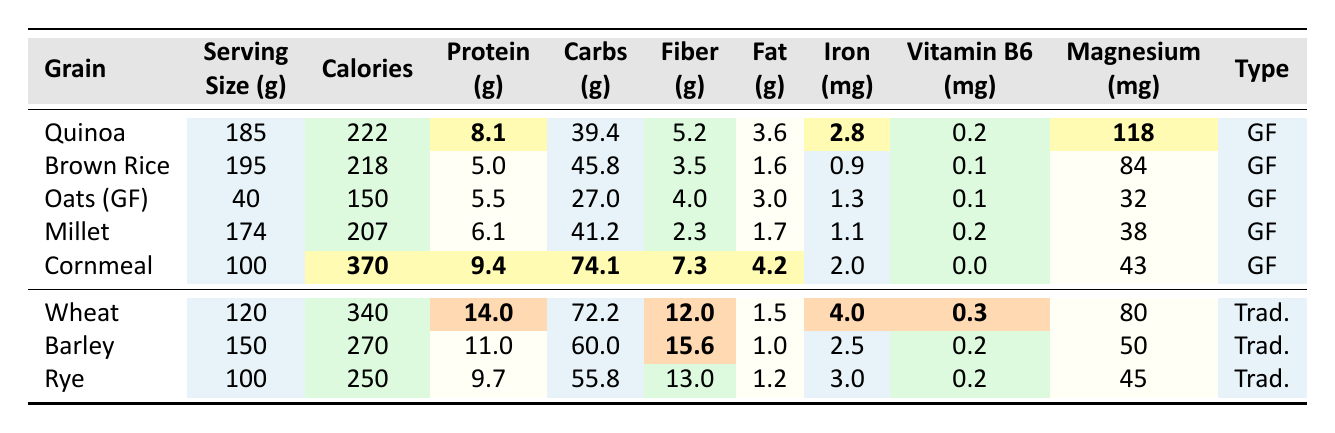What is the calorie content of Cornmeal? The table shows that Cornmeal has a calorie content of 370.
Answer: 370 Which grain has the highest protein content? By comparing the protein content of each grain, Wheat (Whole Grain) has the highest at 14.0 grams.
Answer: Wheat (Whole Grain) How much fiber is in Brown Rice? The table states that Brown Rice contains 3.5 grams of fiber.
Answer: 3.5 What is the total carbohydrate content of Quinoa and Millet? Quinoa has 39.4 grams and Millet has 41.2 grams. The total is 39.4 + 41.2 = 80.6 grams.
Answer: 80.6 Is the vitamin B6 content in Cornmeal higher than in Oats? Cornmeal has 0.0 mg of vitamin B6, while Oats (Gluten-Free) has 0.1 mg. Since 0.0 is not higher than 0.1, the statement is false.
Answer: No What is the average magnesium content of the gluten-free grains listed? The magnesium content is: Quinoa (118), Brown Rice (84), Oats (32), Millet (38), and Cornmeal (43). The total magnesium is 118 + 84 + 32 + 38 + 43 = 315. There are 5 data points, so the average is 315 / 5 = 63.
Answer: 63 Which gluten-free grain has the highest fat content? Comparing the fat content of gluten-free grains, Cornmeal has the highest at 4.2 grams.
Answer: Cornmeal How does the protein content of Rye compare to that of Oats? Rye has 9.7 grams of protein, while Oats (Gluten-Free) has 5.5 grams. Rye has more protein than Oats.
Answer: Rye has more protein What is the difference in iron content between Wheat and Brown Rice? Wheat contains 4.0 mg of iron, while Brown Rice contains 0.9 mg. The difference is 4.0 - 0.9 = 3.1 mg.
Answer: 3.1 mg Which gluten-free grain has the least amount of calories, and what is its value? The table indicates that Oats (Gluten-Free) have the least calories with a value of 150.
Answer: Oats (Gluten-Free) with 150 calories 